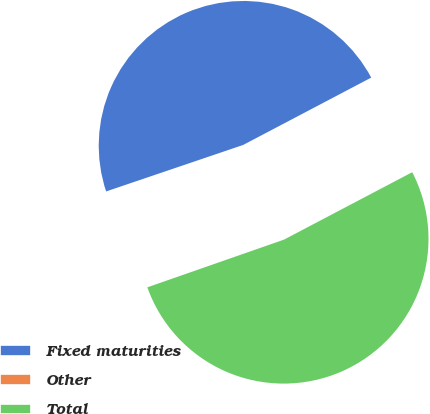Convert chart to OTSL. <chart><loc_0><loc_0><loc_500><loc_500><pie_chart><fcel>Fixed maturities<fcel>Other<fcel>Total<nl><fcel>47.5%<fcel>0.14%<fcel>52.36%<nl></chart> 